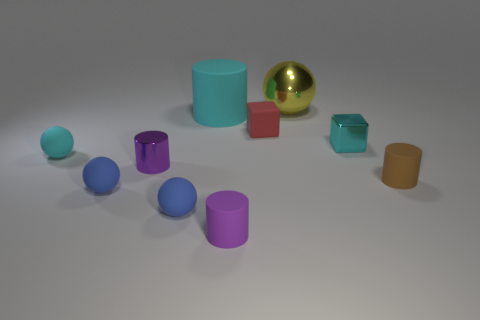Subtract all cyan rubber spheres. How many spheres are left? 3 Subtract all cyan spheres. How many spheres are left? 3 Subtract all yellow cylinders. Subtract all red spheres. How many cylinders are left? 4 Subtract all cubes. How many objects are left? 8 Add 6 cyan shiny blocks. How many cyan shiny blocks are left? 7 Add 10 small yellow rubber things. How many small yellow rubber things exist? 10 Subtract 0 purple spheres. How many objects are left? 10 Subtract all cyan metallic spheres. Subtract all small purple rubber cylinders. How many objects are left? 9 